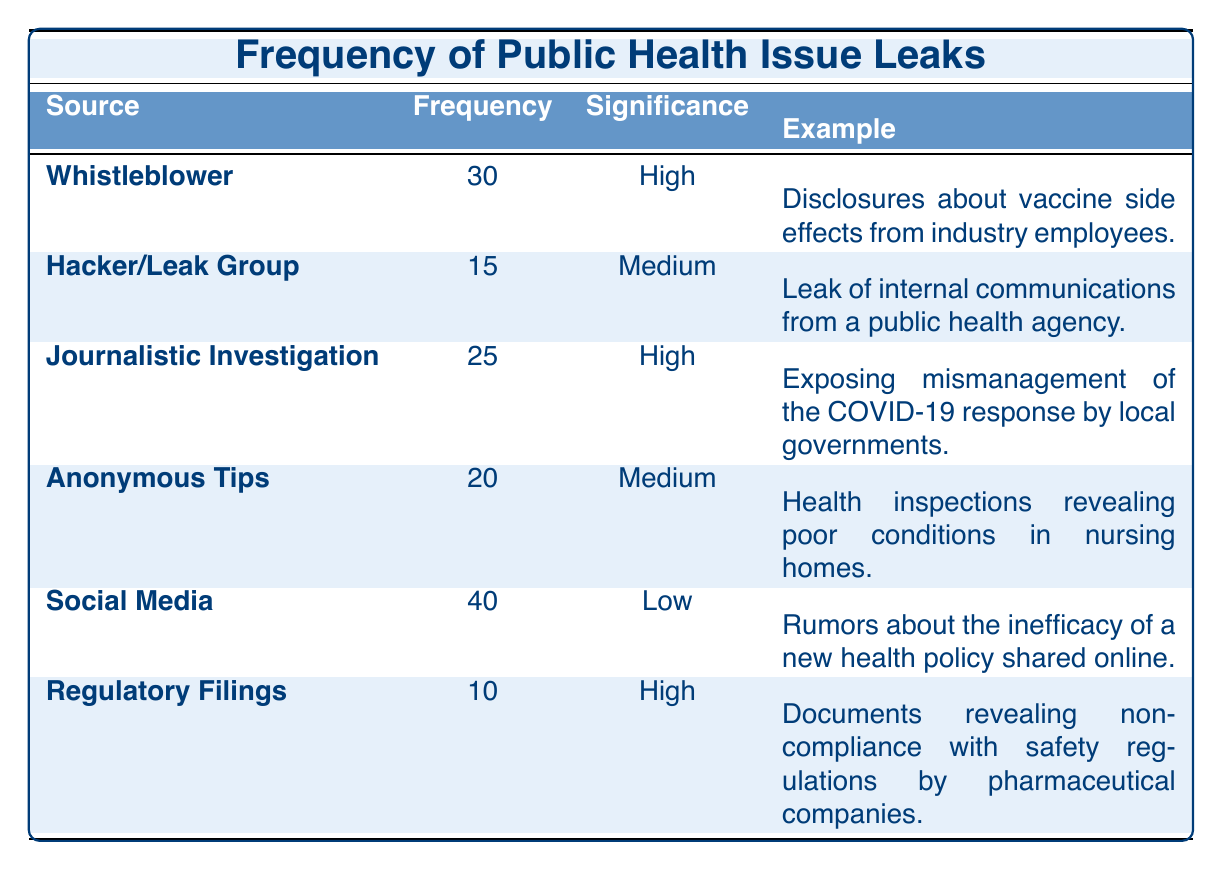What is the frequency of leaks from Social Media? Referring to the table, the row for Social Media shows a frequency value of 40.
Answer: 40 How many leaks are categorized as High significance? The table lists three sources categorized as High significance: Whistleblower, Journalistic Investigation, and Regulatory Filings. Their frequencies are 30, 25, and 10, respectively. So, there are a total of 3 High significance leaks.
Answer: 3 What is the significance of leaks from Hacker/Leak Group? Looking at the Hacker/Leak Group row in the table, the significance is stated as Medium.
Answer: Medium Calculate the total frequency of leaks reported as High significance. To find the total frequency, we add the frequencies for the High significance leaks: 30 (Whistleblower) + 25 (Journalistic Investigation) + 10 (Regulatory Filings) = 65.
Answer: 65 Are there any leaks from Anonymous Tips that have High significance? In the table, the frequency for Anonymous Tips is listed as Medium significance, therefore, there are no High significance leaks from this source.
Answer: No How many leaks have higher frequencies than those from Regulatory Filings? In the table, Regulatory Filings has a frequency of 10. The sources with higher frequencies are Whistleblower (30), Journalistic Investigation (25), Social Media (40), and Anonymous Tips (20). That makes a total of 4 sources with higher frequencies.
Answer: 4 What are the examples of leaks with Medium significance? According to the table, two leaks are identified with Medium significance: Hacker/Leak Group (internal communications from a public health agency) and Anonymous Tips (poor conditions in nursing homes).
Answer: Two examples Is the frequency of leaks from Whistleblower greater than that from Anonymous Tips? The frequency for Whistleblower is 30 and for Anonymous Tips it is 20. Since 30 is greater than 20, this statement is true.
Answer: Yes What is the average frequency of all leaks with Low significance? There is only one source with Low significance: Social Media, which has a frequency of 40. Hence, the average frequency is just this single value: 40 / 1 = 40.
Answer: 40 